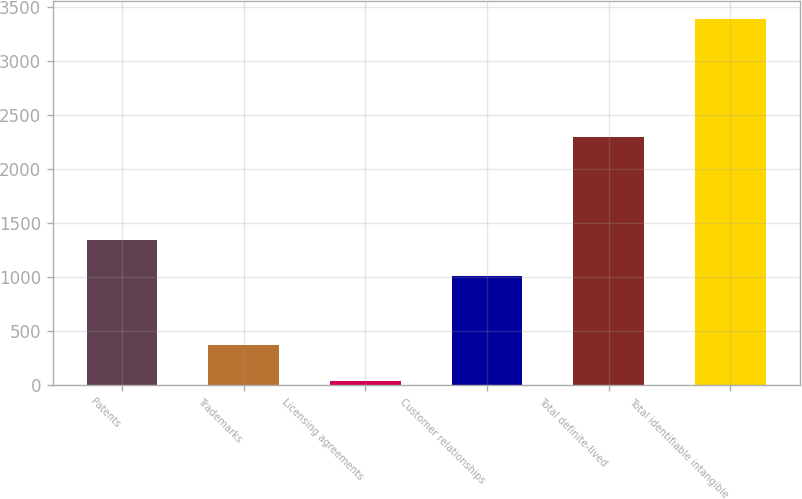Convert chart. <chart><loc_0><loc_0><loc_500><loc_500><bar_chart><fcel>Patents<fcel>Trademarks<fcel>Licensing agreements<fcel>Customer relationships<fcel>Total definite-lived<fcel>Total identifiable intangible<nl><fcel>1339.6<fcel>368.3<fcel>33.5<fcel>1004.8<fcel>2293.1<fcel>3381.5<nl></chart> 